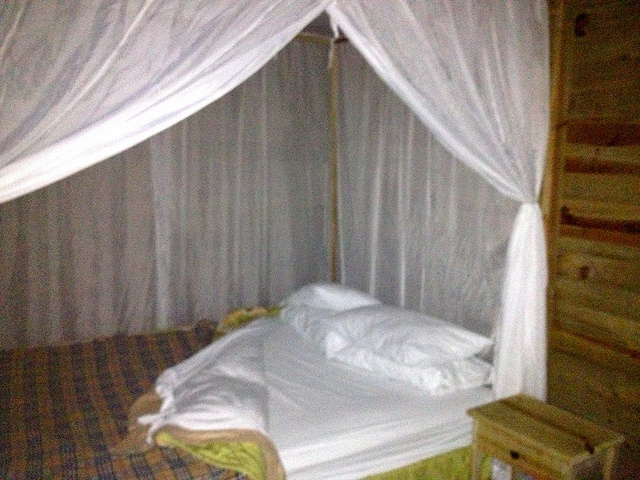Describe the objects in this image and their specific colors. I can see bed in gray, darkgray, lightgray, and black tones and chair in gray, olive, maroon, and black tones in this image. 